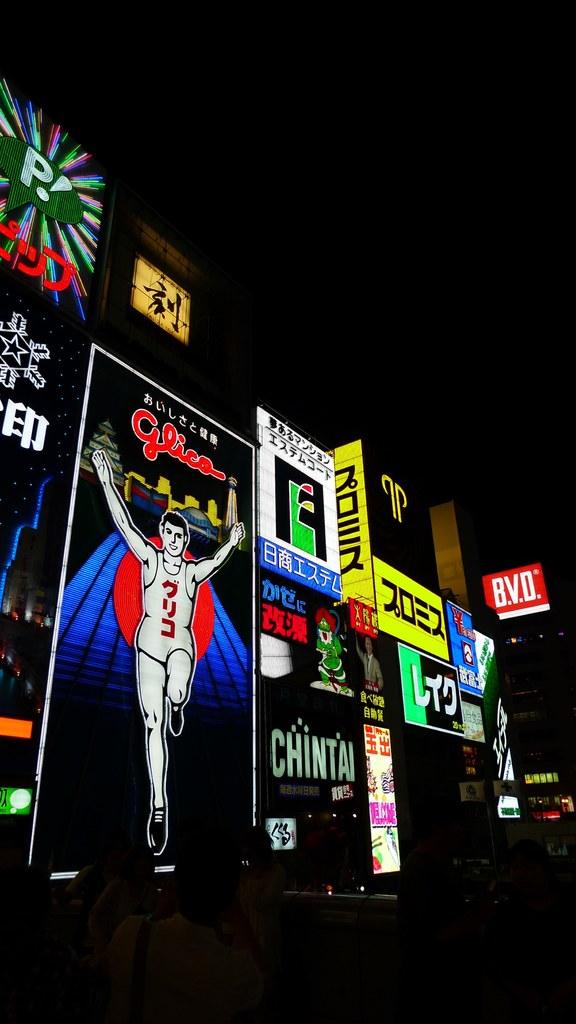What letter is contained within the green conversation cloud?
Your answer should be compact. P. What initials are listed on the red, square sign?
Your response must be concise. Bvd. 